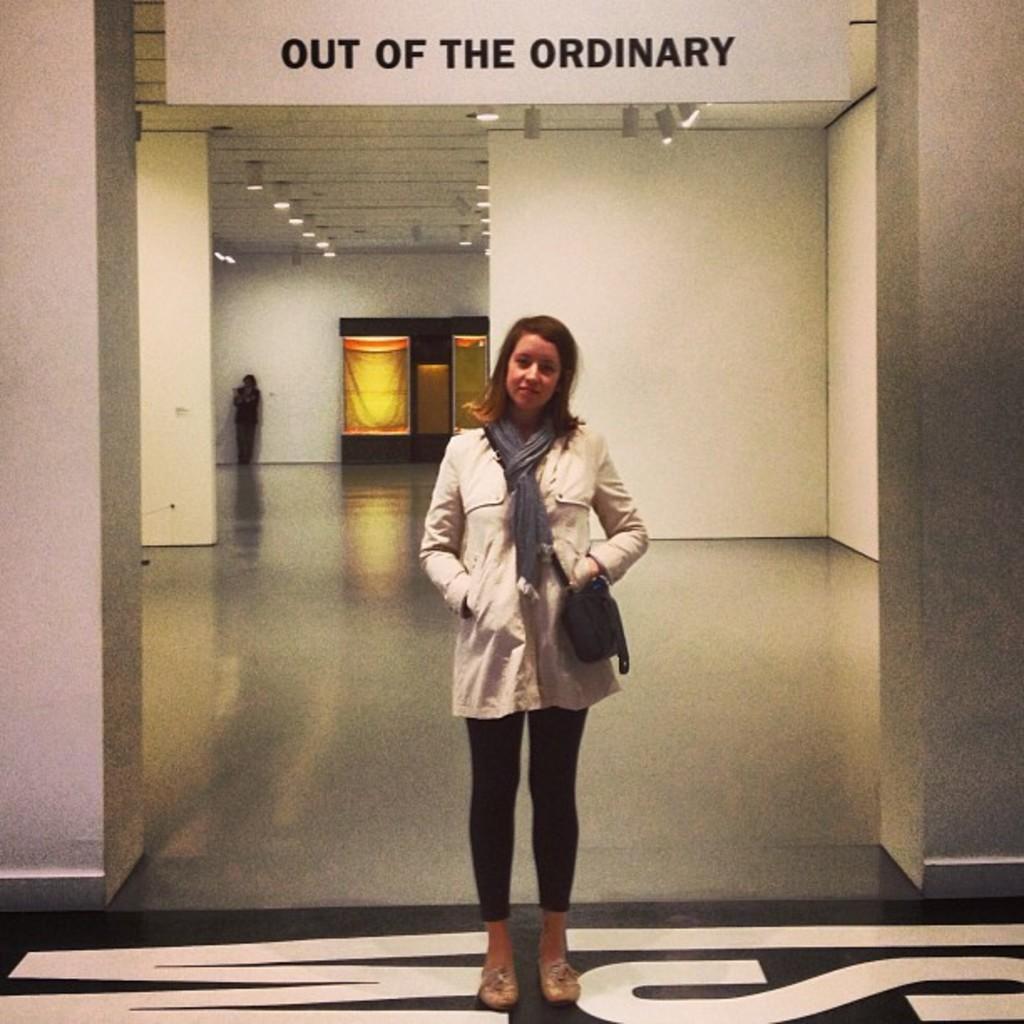How would you summarize this image in a sentence or two? The woman in the middle of the picture is standing. She is wearing a white dress and a black bag. On either side of the picture, we see the white pillars or the white walls. In the background, we see a woman is standing. Behind her, we see a white wall and beside that, we see banners in yellow color. At the top, we see the ceiling of the room and we even see a white color board with some text written on it. 